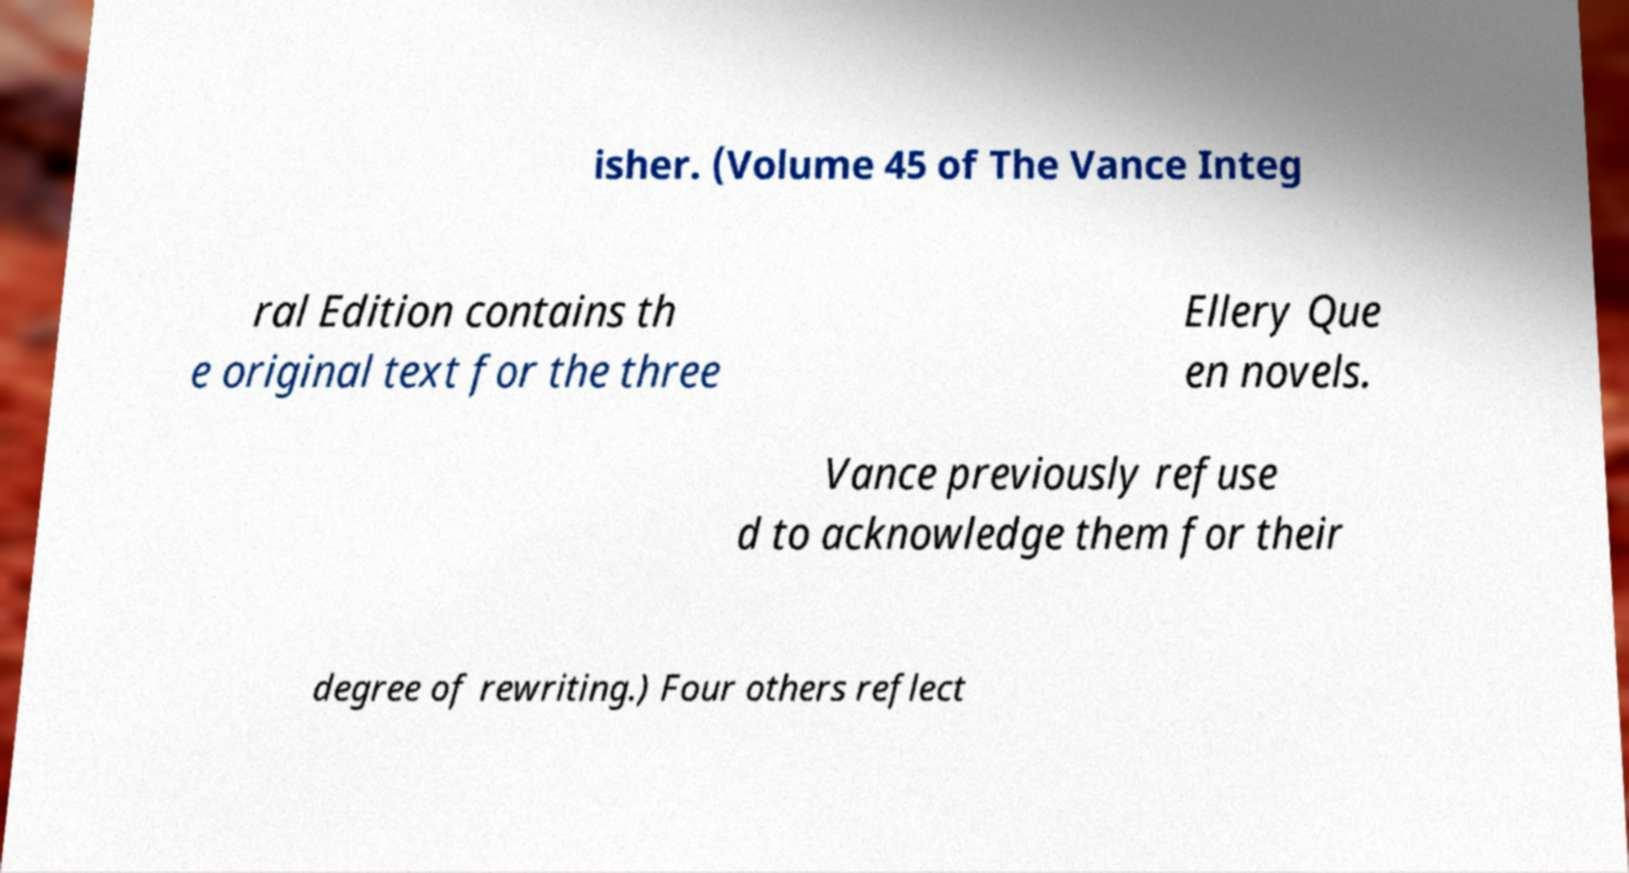I need the written content from this picture converted into text. Can you do that? isher. (Volume 45 of The Vance Integ ral Edition contains th e original text for the three Ellery Que en novels. Vance previously refuse d to acknowledge them for their degree of rewriting.) Four others reflect 